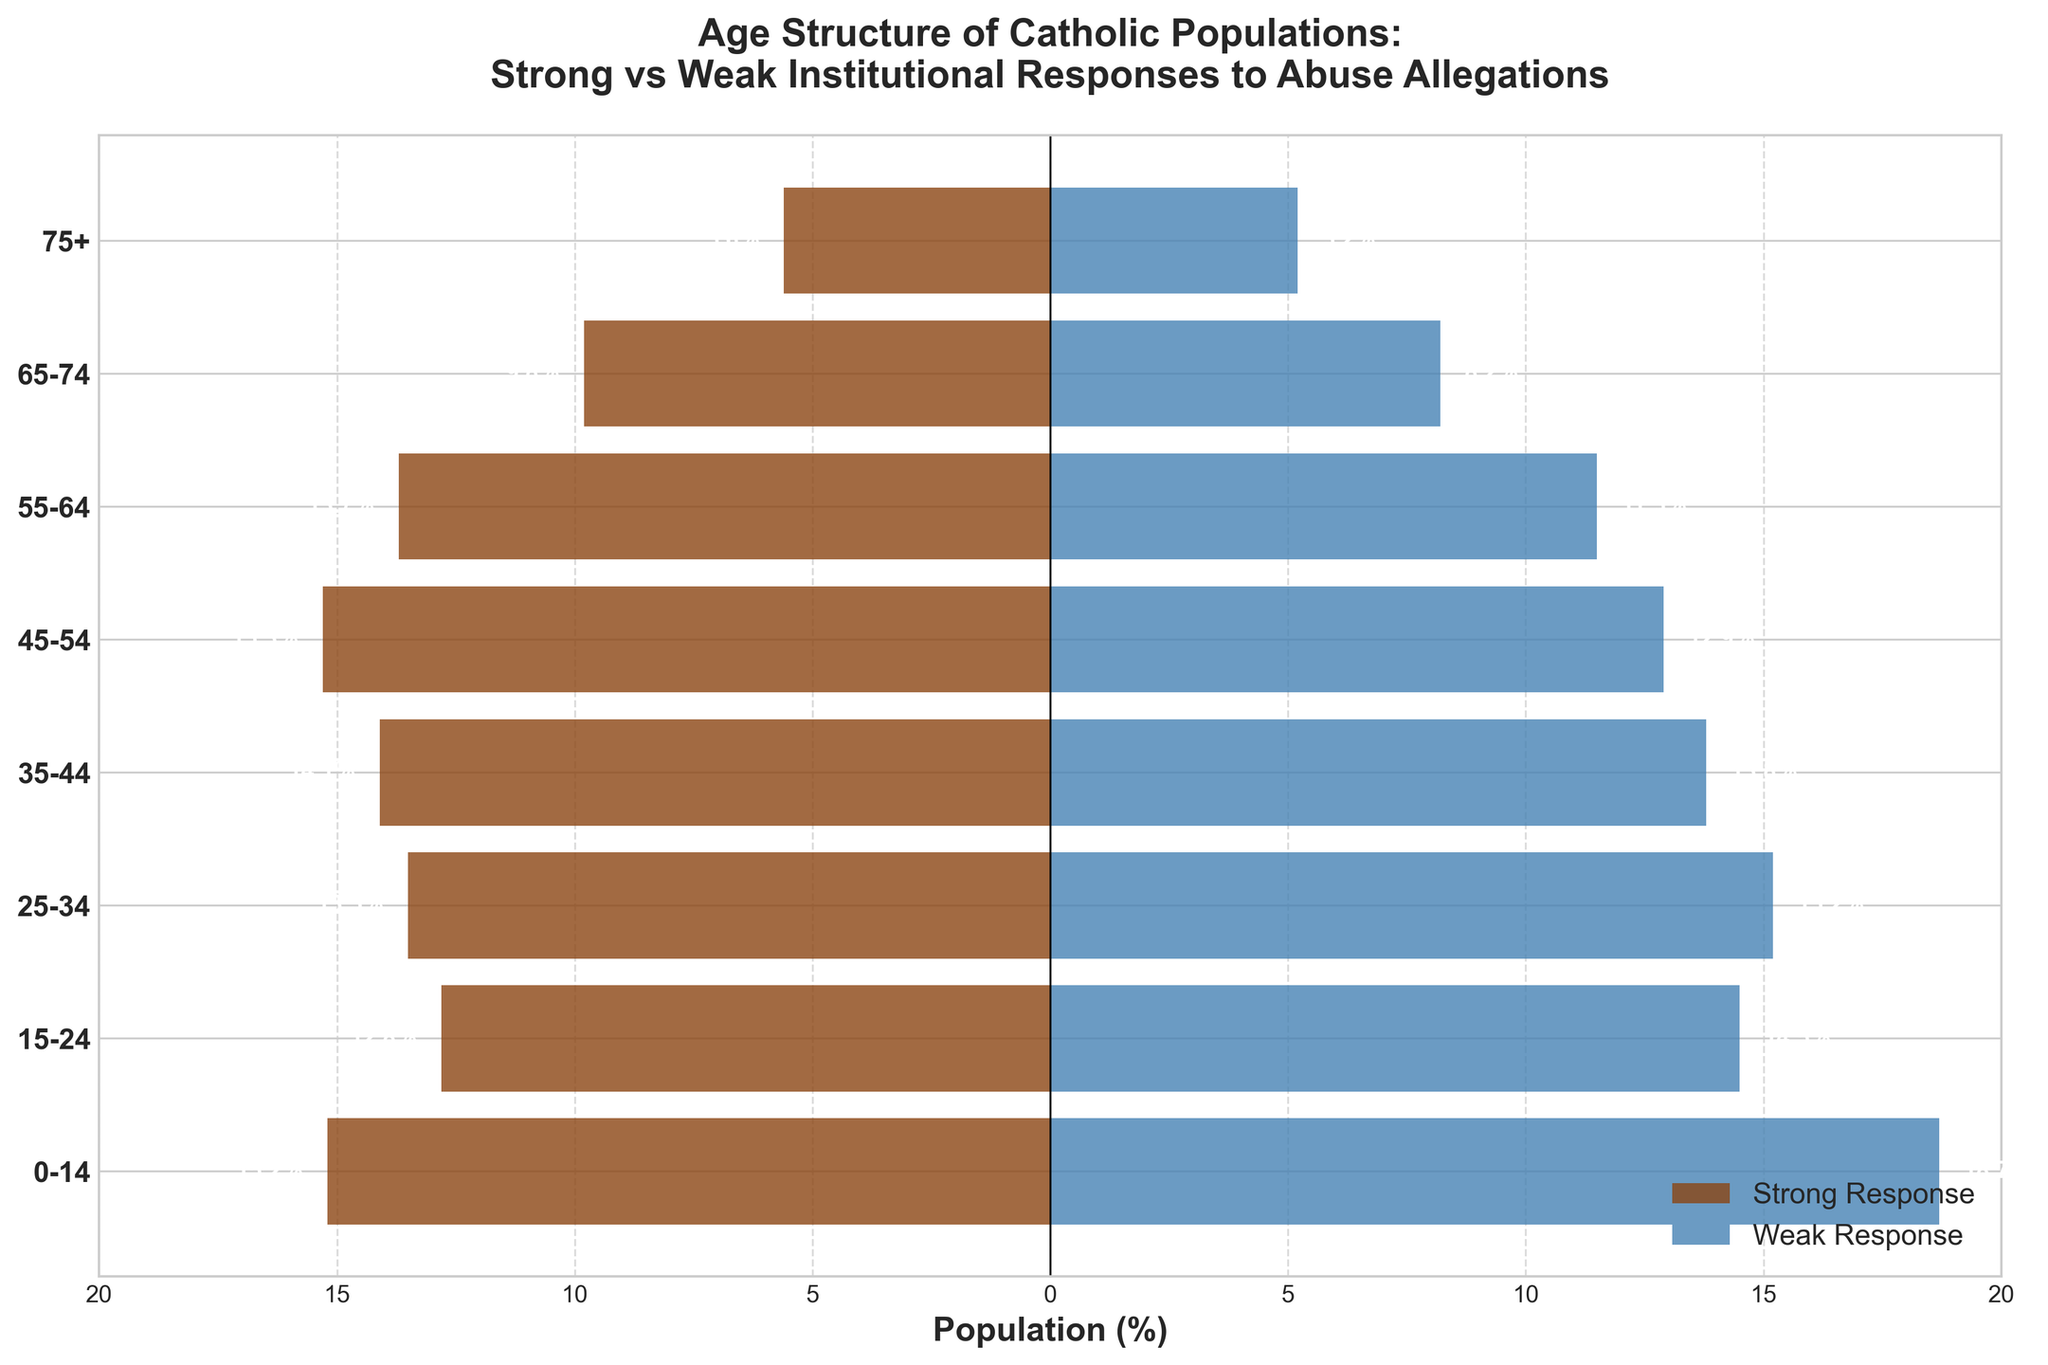What’s the title of the figure? The title is displayed at the top of the figure. It provides context and summarizes the main focus of the data displayed.
Answer: Age Structure of Catholic Populations: Strong vs Weak Institutional Responses to Abuse Allegations What age group has the highest percentage in regions with a strong response? To find this, look at the bars representing the "Strong Response" category, and identify the longest bar.
Answer: 45-54 Which age group shows the greatest difference in percentage between strong and weak responses? To determine this, calculate the difference for each age group by subtracting the percentage of the weak response from the strong response. Identify the age group with the largest absolute value.
Answer: 0-14 What is the percentage of the 25-34 age group in regions with a weak response? Look at the length of the bar corresponding to the 25-34 age group under the "Weak Response" category.
Answer: 15.2% What is the combined percentage of the 65-74 and 75+ age groups in regions with a strong response? Add the percentages of the 65-74 and 75+ age groups for the strong response: 9.8% + 5.6%.
Answer: 15.4% What is the total percentage of the population aged 0-34 in regions with a weak response? Sum the percentages of the 0-14, 15-24, and 25-34 age groups for the weak response: 18.7% + 14.5% + 15.2%.
Answer: 48.4% How does the percentage of the 35-44 age group compare between strong and weak responses? Compare the lengths of the bars for the 35-44 age group in both the strong and weak response categories.
Answer: 14.1% (Strong) vs. 13.8% (Weak) In which age group do regions with a weak response have a higher percentage than regions with a strong response? Identify the age groups where the bar for the "Weak Response" category is longer than the corresponding bar for the "Strong Response" category.
Answer: 0-14, 15-24, 25-34 How many age groups are represented in the figure? Count the number of unique age groups labeled on the y-axis.
Answer: 8 What age group has a nearly equal percentage between strong and weak responses? Compare the lengths of the bars across age groups to find one where the percentages are closest in value.
Answer: 75+ 